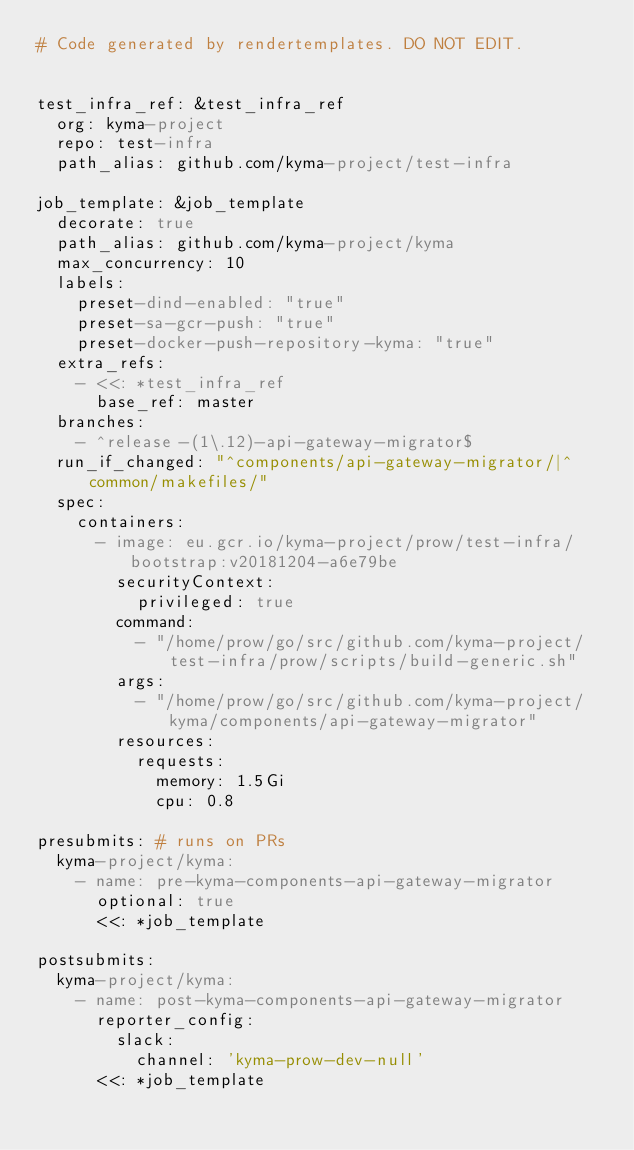<code> <loc_0><loc_0><loc_500><loc_500><_YAML_># Code generated by rendertemplates. DO NOT EDIT.


test_infra_ref: &test_infra_ref
  org: kyma-project
  repo: test-infra
  path_alias: github.com/kyma-project/test-infra

job_template: &job_template
  decorate: true
  path_alias: github.com/kyma-project/kyma
  max_concurrency: 10
  labels:
    preset-dind-enabled: "true"
    preset-sa-gcr-push: "true"
    preset-docker-push-repository-kyma: "true"
  extra_refs:
    - <<: *test_infra_ref
      base_ref: master
  branches:
    - ^release-(1\.12)-api-gateway-migrator$
  run_if_changed: "^components/api-gateway-migrator/|^common/makefiles/"
  spec:
    containers:
      - image: eu.gcr.io/kyma-project/prow/test-infra/bootstrap:v20181204-a6e79be
        securityContext:
          privileged: true
        command:
          - "/home/prow/go/src/github.com/kyma-project/test-infra/prow/scripts/build-generic.sh"
        args:
          - "/home/prow/go/src/github.com/kyma-project/kyma/components/api-gateway-migrator"
        resources:
          requests:
            memory: 1.5Gi
            cpu: 0.8

presubmits: # runs on PRs
  kyma-project/kyma:
    - name: pre-kyma-components-api-gateway-migrator
      optional: true
      <<: *job_template

postsubmits:
  kyma-project/kyma:
    - name: post-kyma-components-api-gateway-migrator
      reporter_config:
        slack:
          channel: 'kyma-prow-dev-null'
      <<: *job_template
</code> 